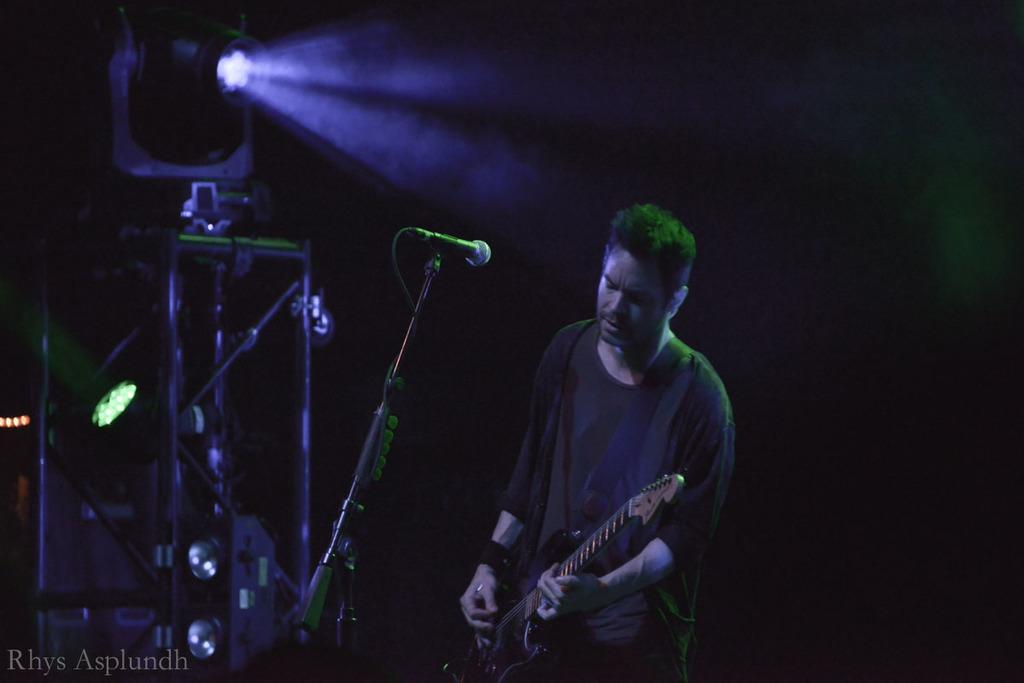What is the main subject of the image? There is a person in the image. What is the person doing in the image? The person is standing in the image. What object is the person holding in the image? The person is holding a guitar in his hand. What type of headwear is the person wearing in the image? There is no headwear visible in the image. What kind of bulb can be seen illuminating the guitar in the image? There is no bulb present in the image, and the guitar is not illuminated. 